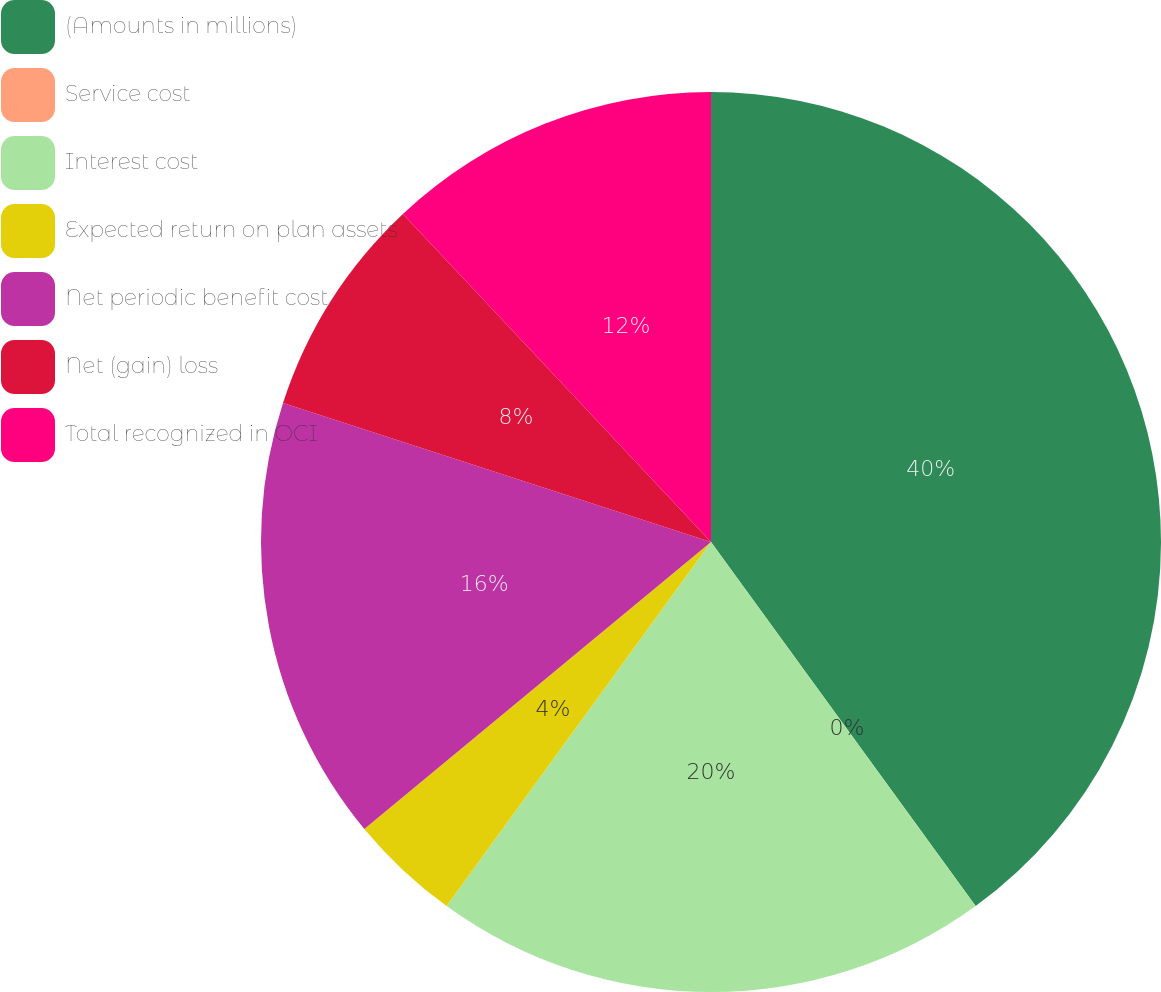Convert chart. <chart><loc_0><loc_0><loc_500><loc_500><pie_chart><fcel>(Amounts in millions)<fcel>Service cost<fcel>Interest cost<fcel>Expected return on plan assets<fcel>Net periodic benefit cost<fcel>Net (gain) loss<fcel>Total recognized in OCI<nl><fcel>39.99%<fcel>0.0%<fcel>20.0%<fcel>4.0%<fcel>16.0%<fcel>8.0%<fcel>12.0%<nl></chart> 